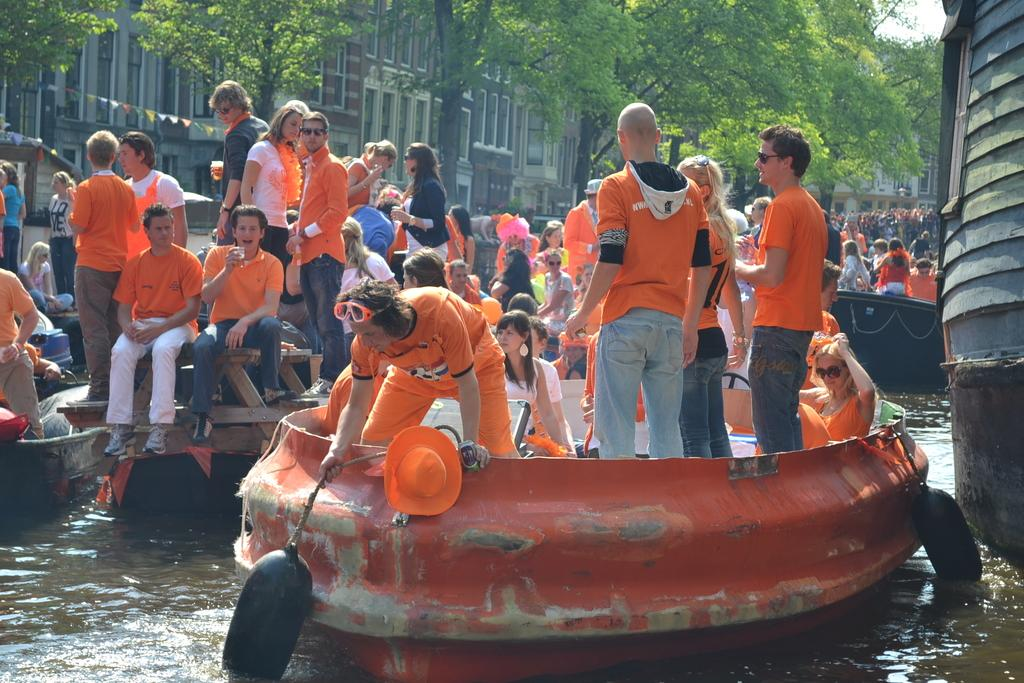What are the people in the image doing? The people in the image are sitting and standing on ships. Where are the ships located? The ships are in the water. What can be seen in the background of the image? There are buildings and trees in the background of the image. What type of print can be seen on the table in the image? There is no table present in the image, so it is not possible to determine if there is any print on it. 